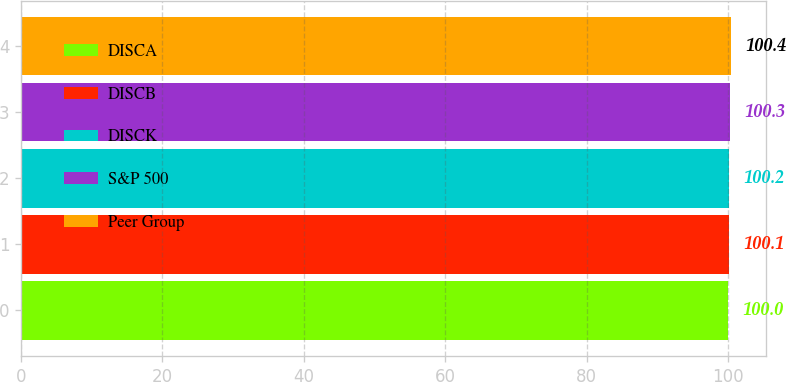Convert chart to OTSL. <chart><loc_0><loc_0><loc_500><loc_500><bar_chart><fcel>DISCA<fcel>DISCB<fcel>DISCK<fcel>S&P 500<fcel>Peer Group<nl><fcel>100<fcel>100.1<fcel>100.2<fcel>100.3<fcel>100.4<nl></chart> 